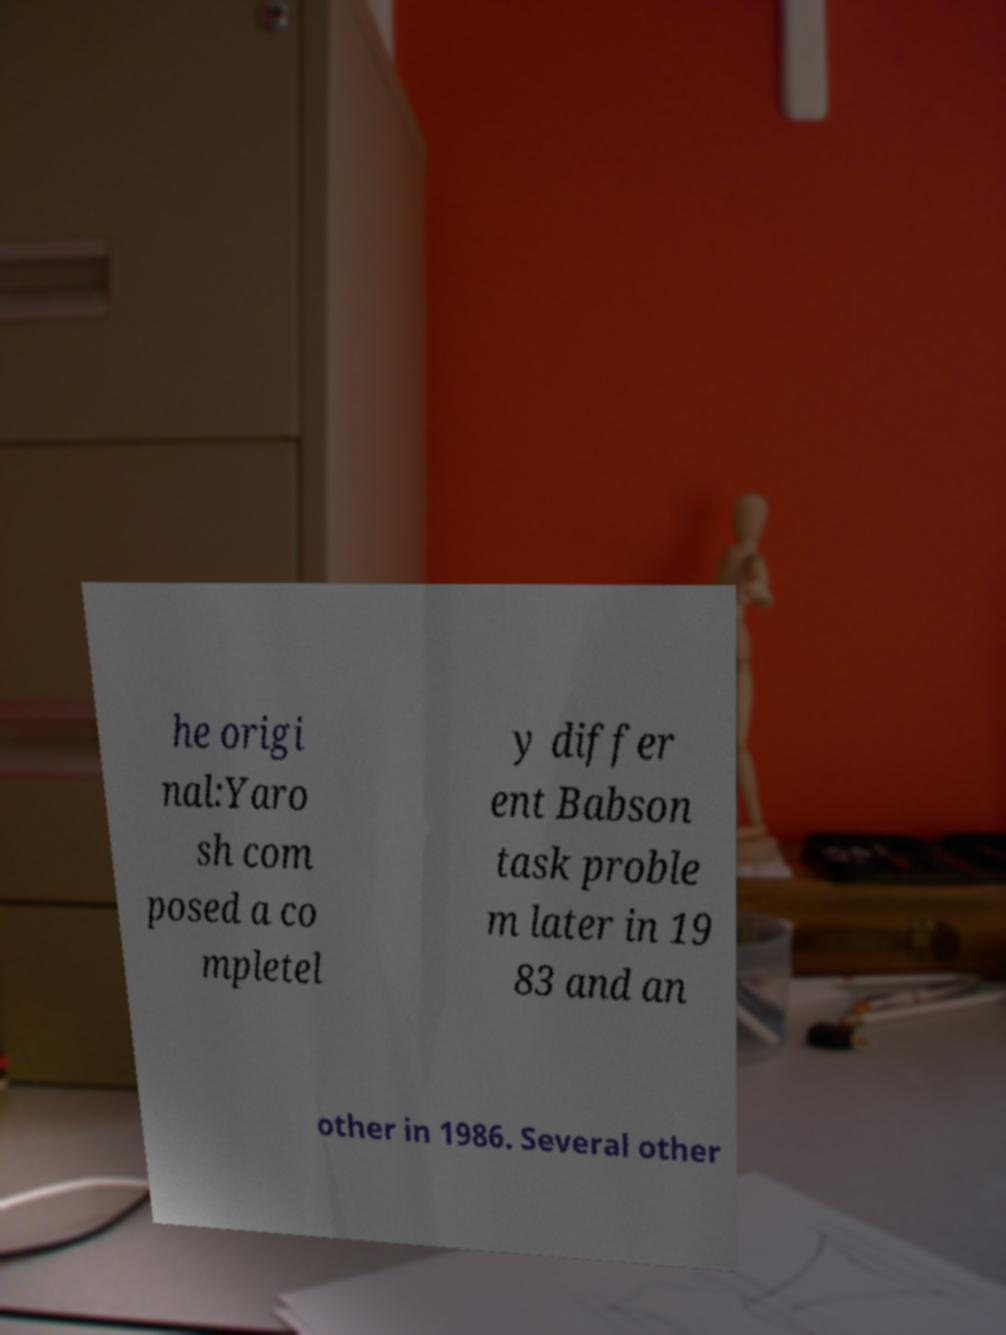What messages or text are displayed in this image? I need them in a readable, typed format. he origi nal:Yaro sh com posed a co mpletel y differ ent Babson task proble m later in 19 83 and an other in 1986. Several other 